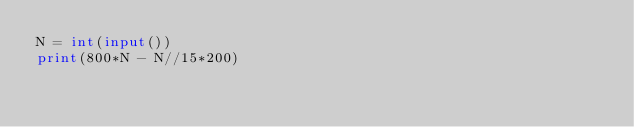Convert code to text. <code><loc_0><loc_0><loc_500><loc_500><_Python_>N = int(input())
print(800*N - N//15*200)</code> 